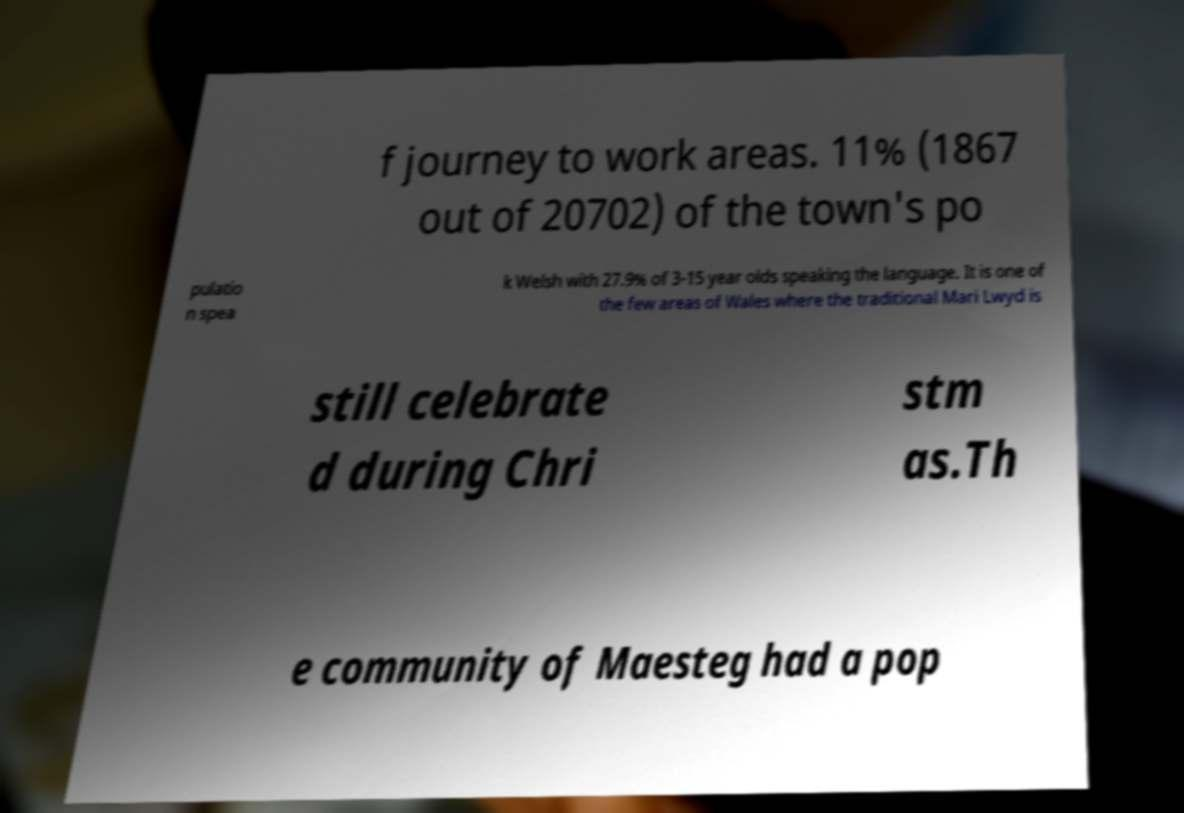There's text embedded in this image that I need extracted. Can you transcribe it verbatim? f journey to work areas. 11% (1867 out of 20702) of the town's po pulatio n spea k Welsh with 27.9% of 3-15 year olds speaking the language. It is one of the few areas of Wales where the traditional Mari Lwyd is still celebrate d during Chri stm as.Th e community of Maesteg had a pop 